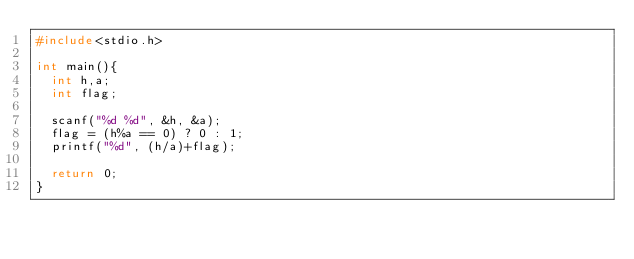Convert code to text. <code><loc_0><loc_0><loc_500><loc_500><_C_>#include<stdio.h>

int main(){
  int h,a;
  int flag;
  
  scanf("%d %d", &h, &a);
  flag = (h%a == 0) ? 0 : 1;
  printf("%d", (h/a)+flag);
  
  return 0;
}</code> 